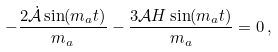Convert formula to latex. <formula><loc_0><loc_0><loc_500><loc_500>- \frac { 2 \dot { \mathcal { A } } \sin ( m _ { a } t ) } { m _ { a } } - \frac { 3 \mathcal { A } H \sin ( m _ { a } t ) } { m _ { a } } = 0 \, ,</formula> 